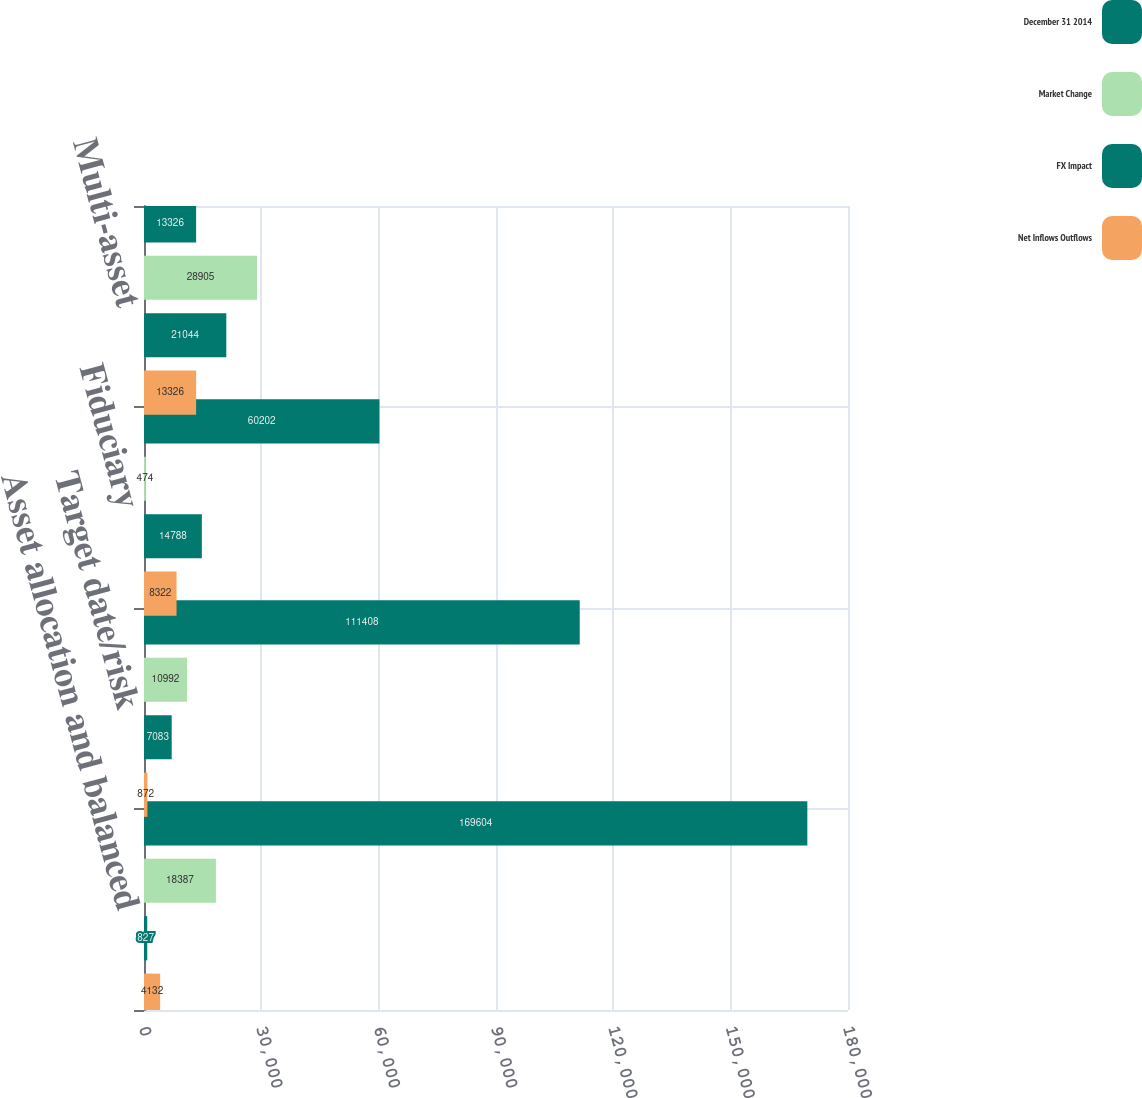Convert chart. <chart><loc_0><loc_0><loc_500><loc_500><stacked_bar_chart><ecel><fcel>Asset allocation and balanced<fcel>Target date/risk<fcel>Fiduciary<fcel>Multi-asset<nl><fcel>December 31 2014<fcel>169604<fcel>111408<fcel>60202<fcel>13326<nl><fcel>Market Change<fcel>18387<fcel>10992<fcel>474<fcel>28905<nl><fcel>FX Impact<fcel>827<fcel>7083<fcel>14788<fcel>21044<nl><fcel>Net Inflows Outflows<fcel>4132<fcel>872<fcel>8322<fcel>13326<nl></chart> 